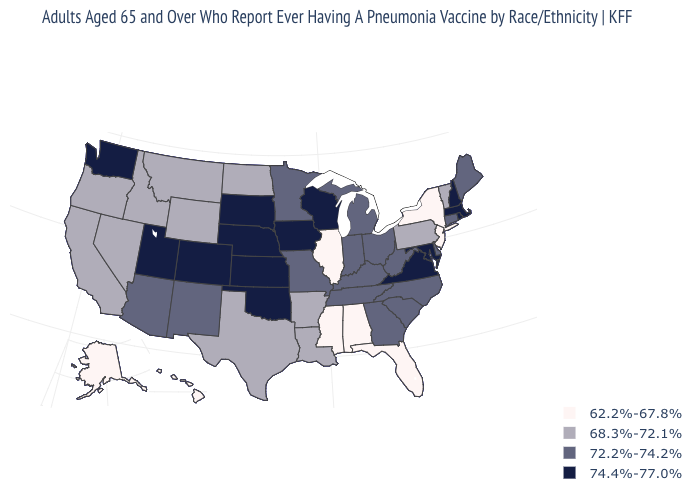What is the lowest value in the MidWest?
Short answer required. 62.2%-67.8%. What is the value of Illinois?
Quick response, please. 62.2%-67.8%. Among the states that border Idaho , which have the lowest value?
Give a very brief answer. Montana, Nevada, Oregon, Wyoming. Does New Mexico have the same value as Kentucky?
Write a very short answer. Yes. What is the value of South Carolina?
Be succinct. 72.2%-74.2%. Does the map have missing data?
Answer briefly. No. Name the states that have a value in the range 72.2%-74.2%?
Give a very brief answer. Arizona, Connecticut, Delaware, Georgia, Indiana, Kentucky, Maine, Michigan, Minnesota, Missouri, New Mexico, North Carolina, Ohio, South Carolina, Tennessee, West Virginia. Name the states that have a value in the range 68.3%-72.1%?
Concise answer only. Arkansas, California, Idaho, Louisiana, Montana, Nevada, North Dakota, Oregon, Pennsylvania, Texas, Vermont, Wyoming. What is the highest value in the USA?
Give a very brief answer. 74.4%-77.0%. What is the lowest value in states that border Montana?
Give a very brief answer. 68.3%-72.1%. Which states have the lowest value in the South?
Answer briefly. Alabama, Florida, Mississippi. What is the highest value in the USA?
Answer briefly. 74.4%-77.0%. What is the value of Iowa?
Concise answer only. 74.4%-77.0%. Does the first symbol in the legend represent the smallest category?
Answer briefly. Yes. 